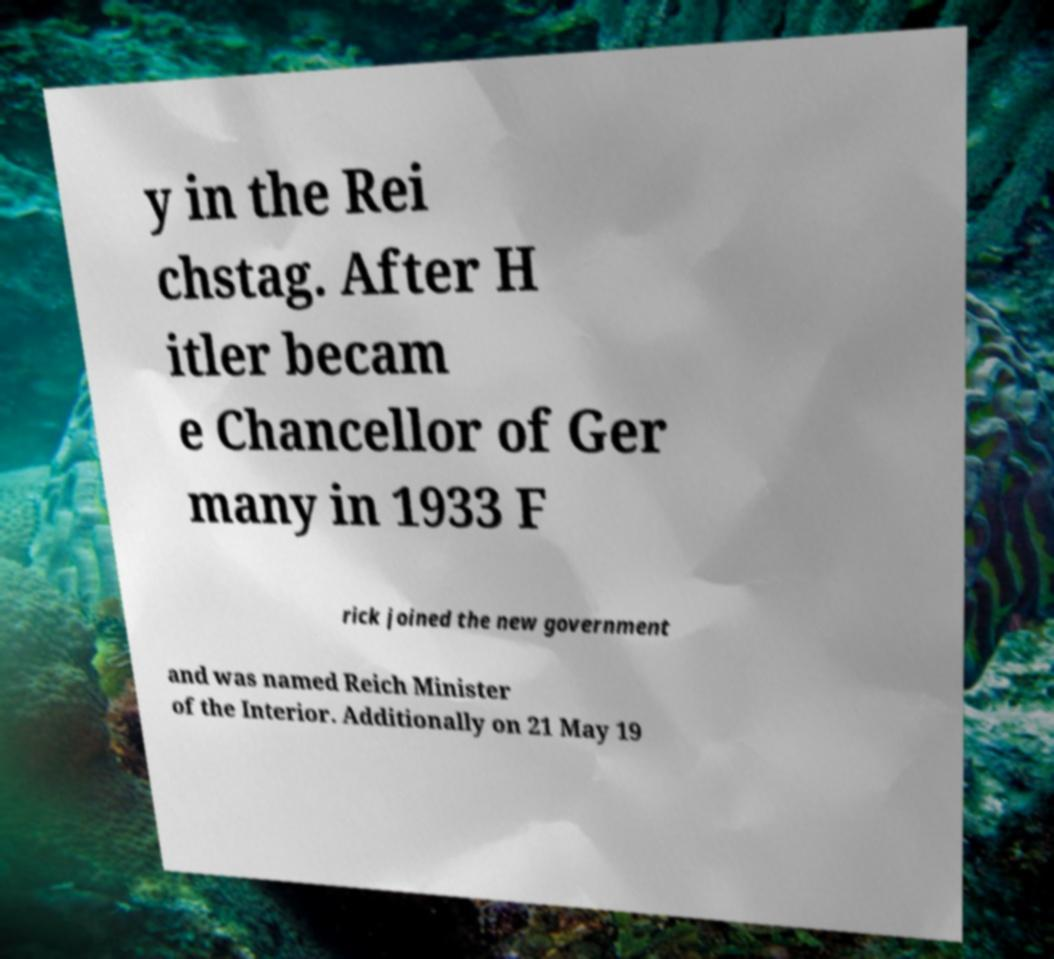For documentation purposes, I need the text within this image transcribed. Could you provide that? y in the Rei chstag. After H itler becam e Chancellor of Ger many in 1933 F rick joined the new government and was named Reich Minister of the Interior. Additionally on 21 May 19 